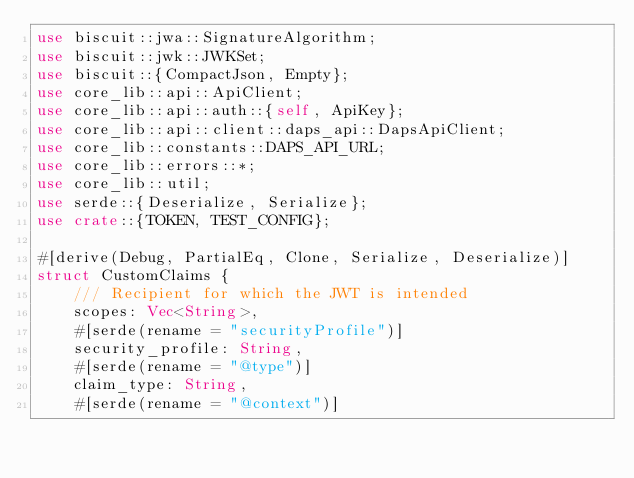<code> <loc_0><loc_0><loc_500><loc_500><_Rust_>use biscuit::jwa::SignatureAlgorithm;
use biscuit::jwk::JWKSet;
use biscuit::{CompactJson, Empty};
use core_lib::api::ApiClient;
use core_lib::api::auth::{self, ApiKey};
use core_lib::api::client::daps_api::DapsApiClient;
use core_lib::constants::DAPS_API_URL;
use core_lib::errors::*;
use core_lib::util;
use serde::{Deserialize, Serialize};
use crate::{TOKEN, TEST_CONFIG};

#[derive(Debug, PartialEq, Clone, Serialize, Deserialize)]
struct CustomClaims {
    /// Recipient for which the JWT is intended
    scopes: Vec<String>,
    #[serde(rename = "securityProfile")]
    security_profile: String,
    #[serde(rename = "@type")]
    claim_type: String,
    #[serde(rename = "@context")]</code> 